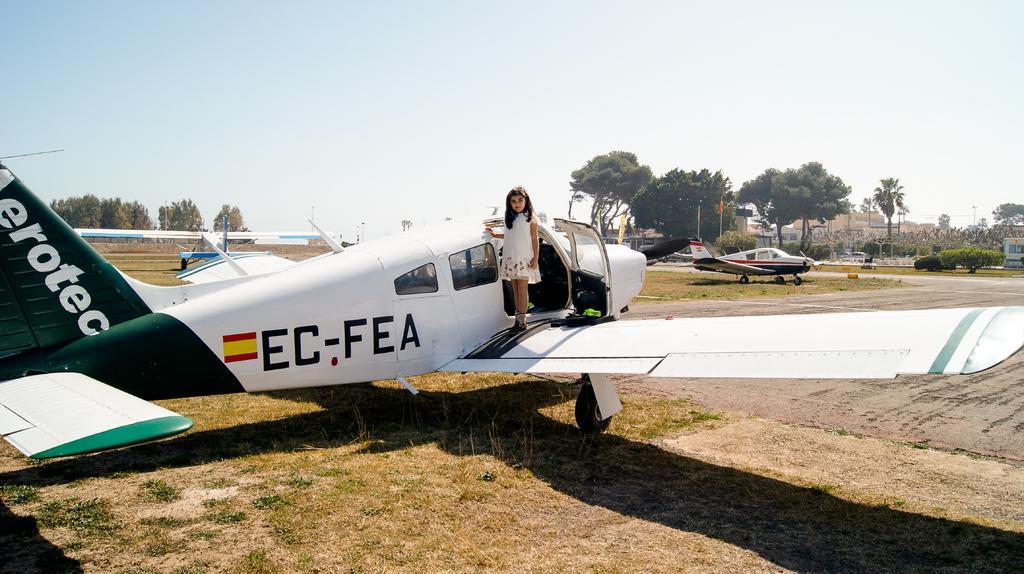How would you summarize this image in a sentence or two? In the foreground of this picture, there is a girl standing on an airplane which is on the grass. In the background, there are few airplanes, flags, plants, trees and the sky. 